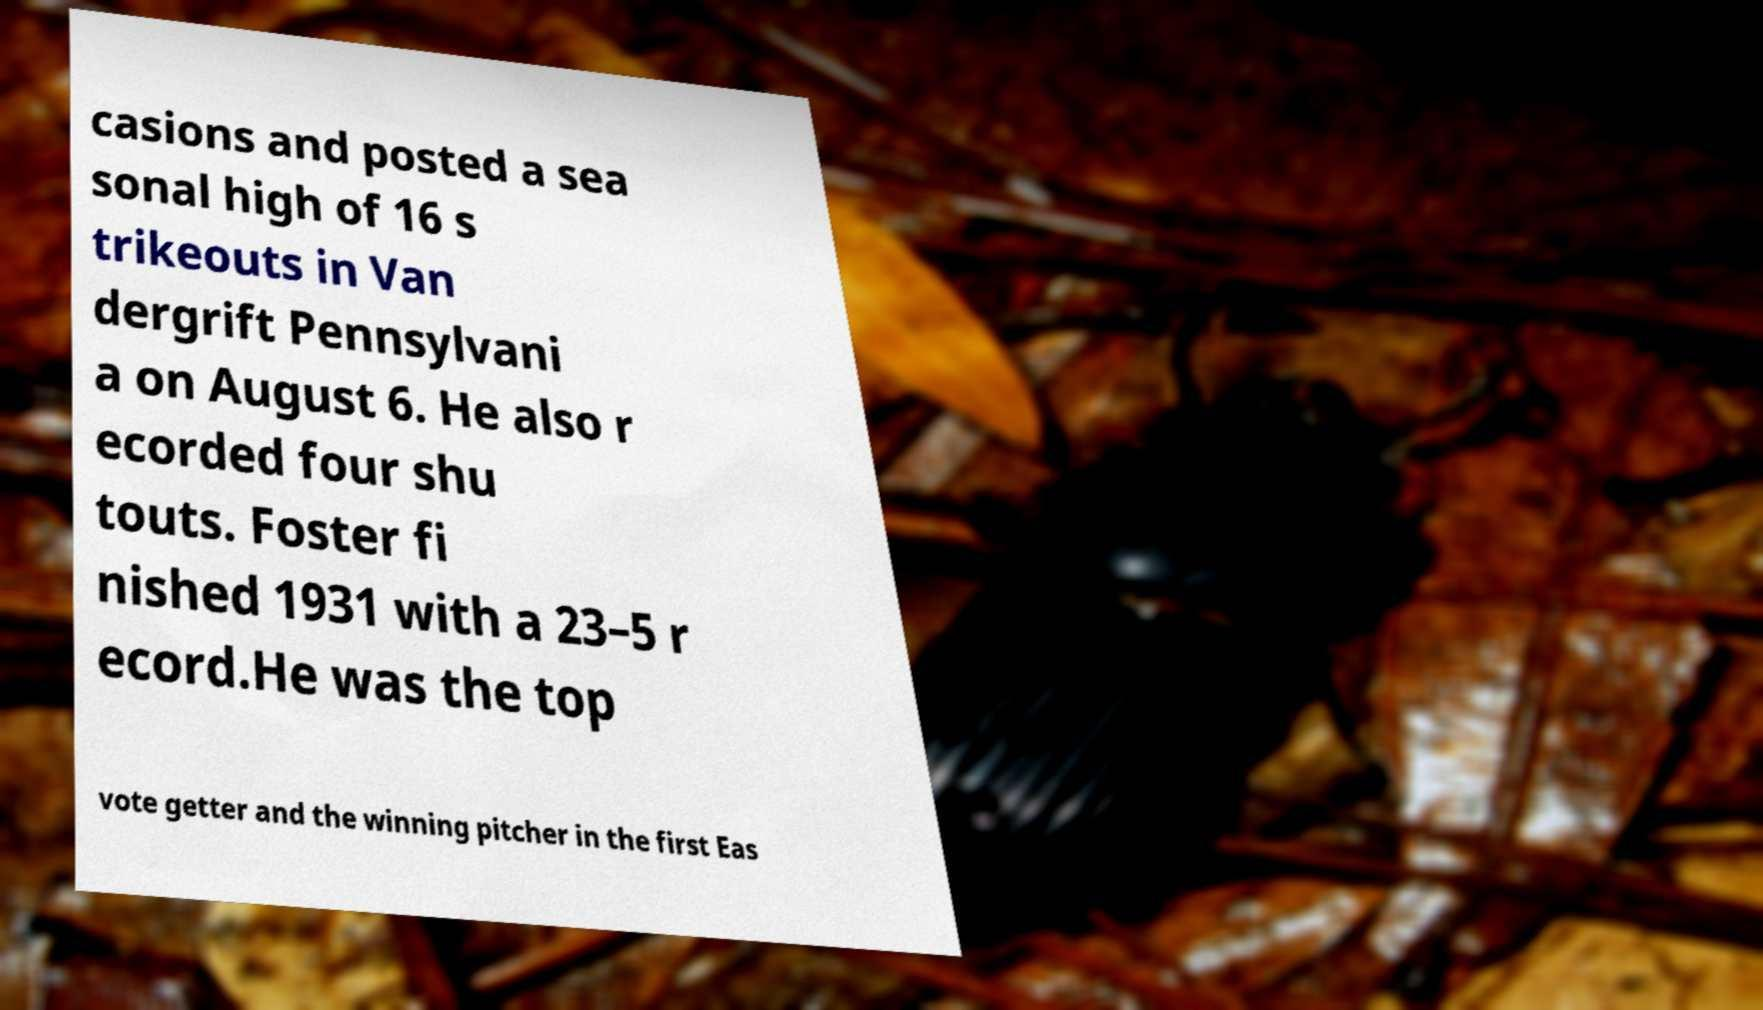Could you extract and type out the text from this image? casions and posted a sea sonal high of 16 s trikeouts in Van dergrift Pennsylvani a on August 6. He also r ecorded four shu touts. Foster fi nished 1931 with a 23–5 r ecord.He was the top vote getter and the winning pitcher in the first Eas 